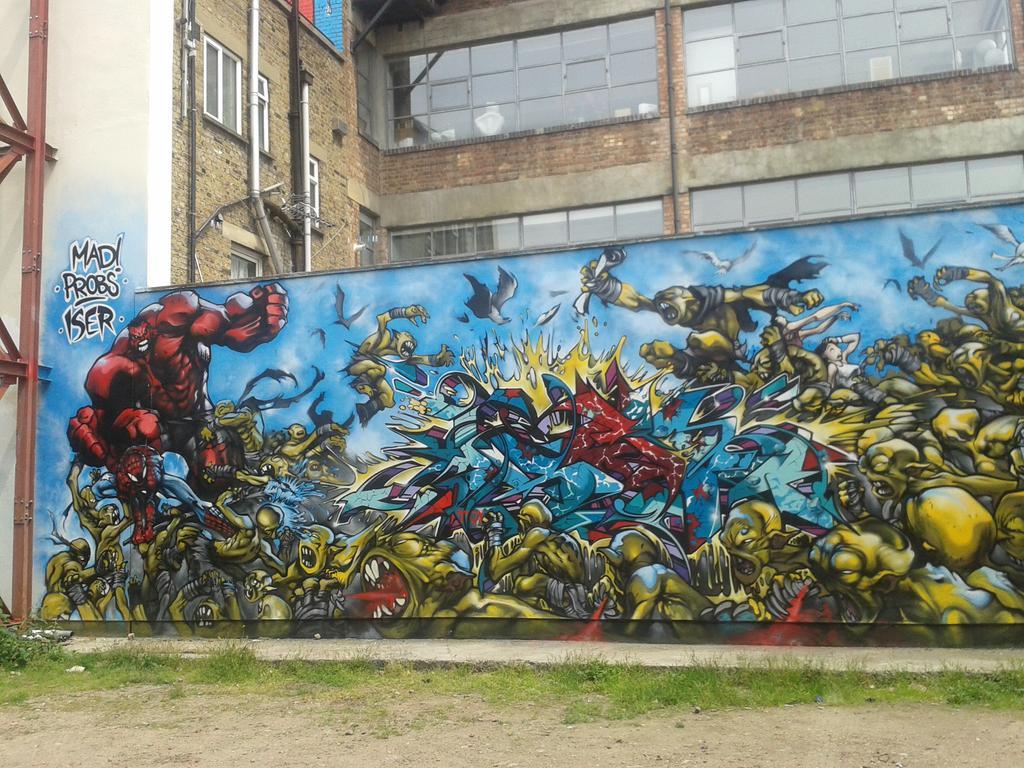How would you summarize this image in a sentence or two? In the image there is a wall and there are some images of dragons are painted on the wall, behind that there is a building and it is built with bricks and there are a lot of windows to the building. 